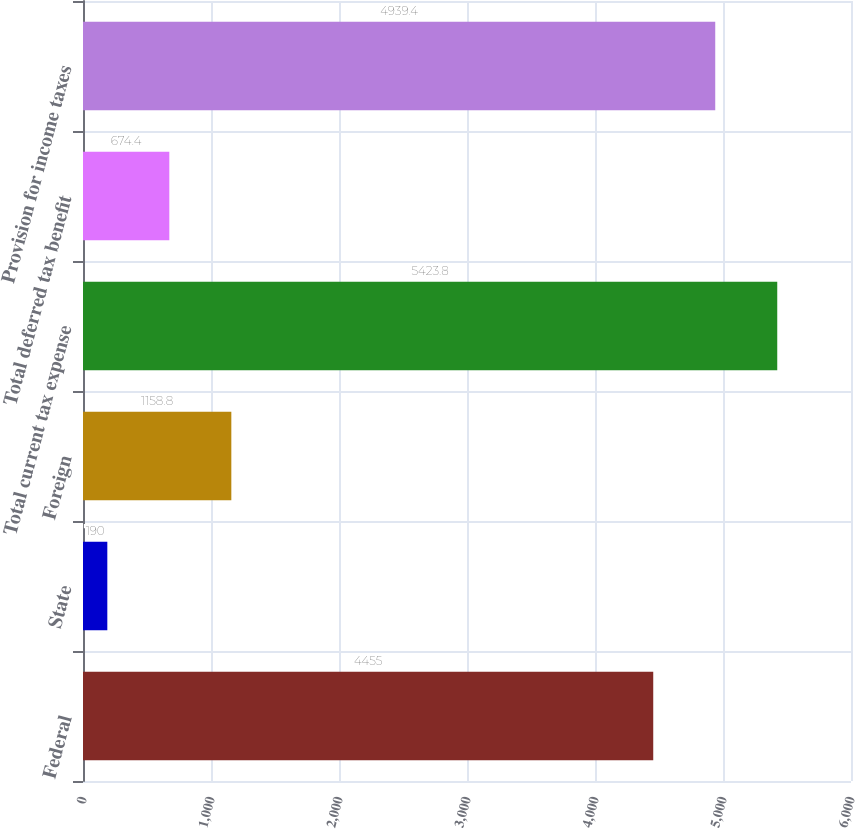Convert chart to OTSL. <chart><loc_0><loc_0><loc_500><loc_500><bar_chart><fcel>Federal<fcel>State<fcel>Foreign<fcel>Total current tax expense<fcel>Total deferred tax benefit<fcel>Provision for income taxes<nl><fcel>4455<fcel>190<fcel>1158.8<fcel>5423.8<fcel>674.4<fcel>4939.4<nl></chart> 